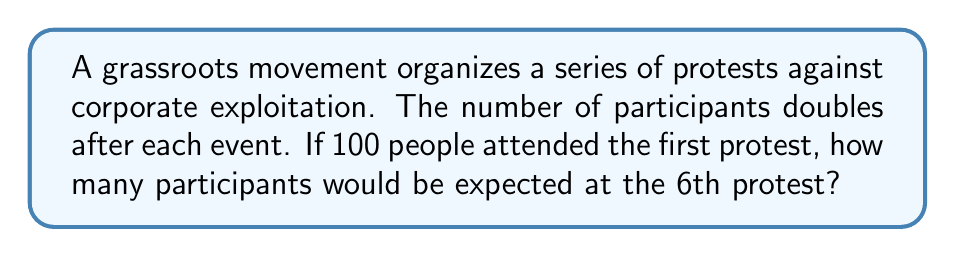Teach me how to tackle this problem. Let's approach this step-by-step:

1) We start with 100 people at the first protest.
2) The number doubles after each event, which means we're dealing with exponential growth.
3) We can represent this with the exponential function:

   $P(n) = 100 \cdot 2^{n-1}$

   Where $P(n)$ is the number of participants at the $n$th protest.

4) We want to find $P(6)$, so let's substitute $n=6$:

   $P(6) = 100 \cdot 2^{6-1} = 100 \cdot 2^5$

5) Now let's calculate $2^5$:
   
   $2^5 = 2 \cdot 2 \cdot 2 \cdot 2 \cdot 2 = 32$

6) Finally, we multiply:

   $100 \cdot 32 = 3200$

Therefore, 3200 participants would be expected at the 6th protest.
Answer: 3200 participants 